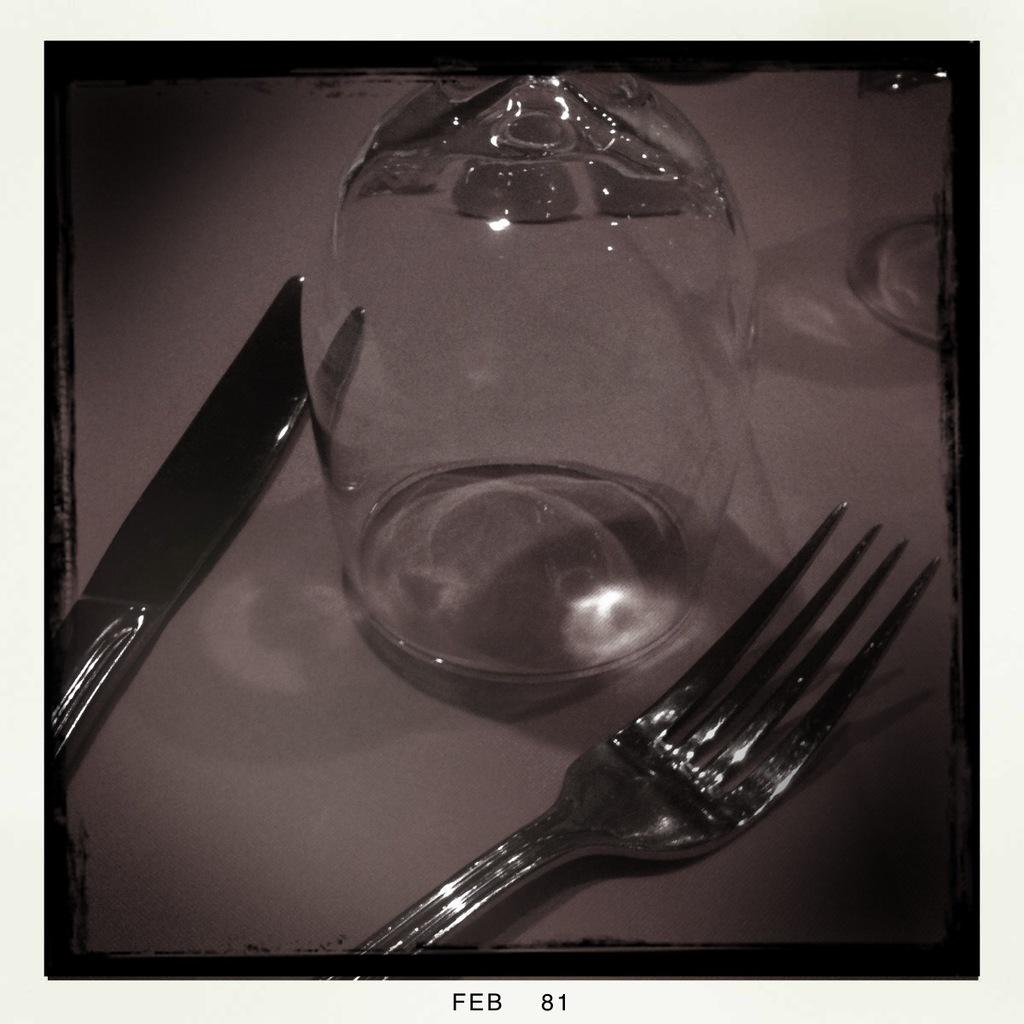What type of glassware is visible in the image? There is a glass in the image. What other utensils are present in the image? There is a knife and a fork in the image. Where are the glass, knife, and fork located? All three items are on a surface in the image. Can you describe any text or writing visible in the image? Yes, there is writing visible in the image. Where is the dock located in the image? There is no dock present in the image. What type of calendar is visible in the image? There is no calendar present in the image. 